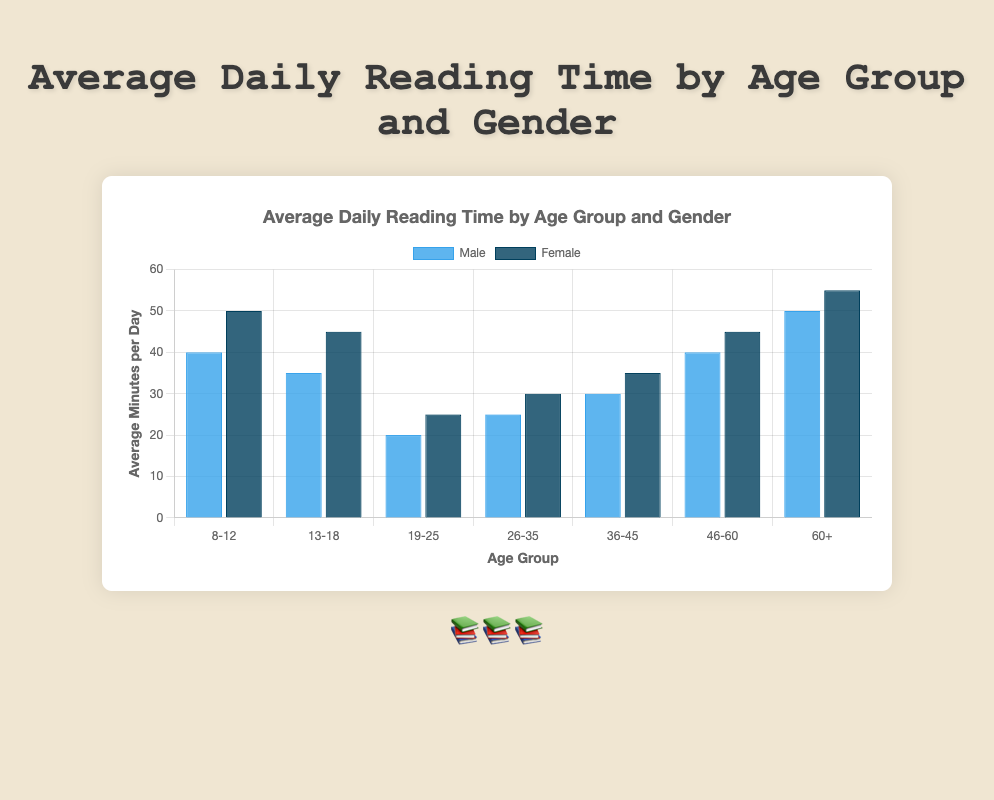Which age group has the highest average daily reading time for females? Look for the bar representing the female gender with the highest value. The age group 60+ for females has the highest average daily reading time of 55 minutes.
Answer: 60+ Compare the average daily reading time of males aged 19-25 to that of females aged 26-35. Which group reads more and by how much? The average daily reading time for males aged 19-25 is 20 minutes and for females aged 26-35 is 30 minutes. Subtracting 20 from 30 tells us that females aged 26-35 read more by 10 minutes.
Answer: Females aged 26-35 read 10 minutes more What is the difference in average daily reading time between males and females aged 46-60? The average daily reading time for males aged 46-60 is 40 minutes, and for females, it is 45 minutes. Subtracting 40 from 45 gives the difference as 5 minutes.
Answer: 5 minutes How much more do females aged 13-18 read compared to males aged the same group? The average daily reading time for females aged 13-18 is 45 minutes and for males is 35 minutes. Subtracting 35 from 45 shows females read 10 minutes more.
Answer: 10 minutes What is the total average daily reading time for males aged 8-12 and 36-45 combined? The average daily reading time for males aged 8-12 is 40 minutes, and for males aged 36-45 is 30 minutes. Adding these values gives the total as 40 + 30 = 70 minutes.
Answer: 70 minutes What is the average (mean) daily reading time across all age groups for females? Sum the average reading times for all female age groups (50 + 45 + 25 + 30 + 35 + 45 + 55 = 285) and divide by the number of age groups (7), resulting in 285 / 7 = 40.71 minutes.
Answer: 40.71 minutes Which color represents females in the bar chart? Identify the color associated with the female category, which is the darker shade of blue.
Answer: Dark blue 